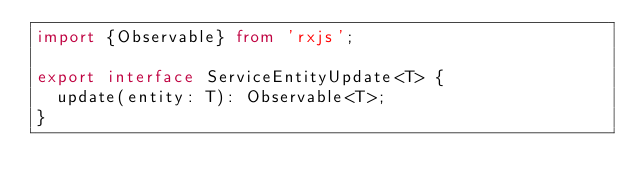<code> <loc_0><loc_0><loc_500><loc_500><_TypeScript_>import {Observable} from 'rxjs';

export interface ServiceEntityUpdate<T> {
  update(entity: T): Observable<T>;
}
</code> 